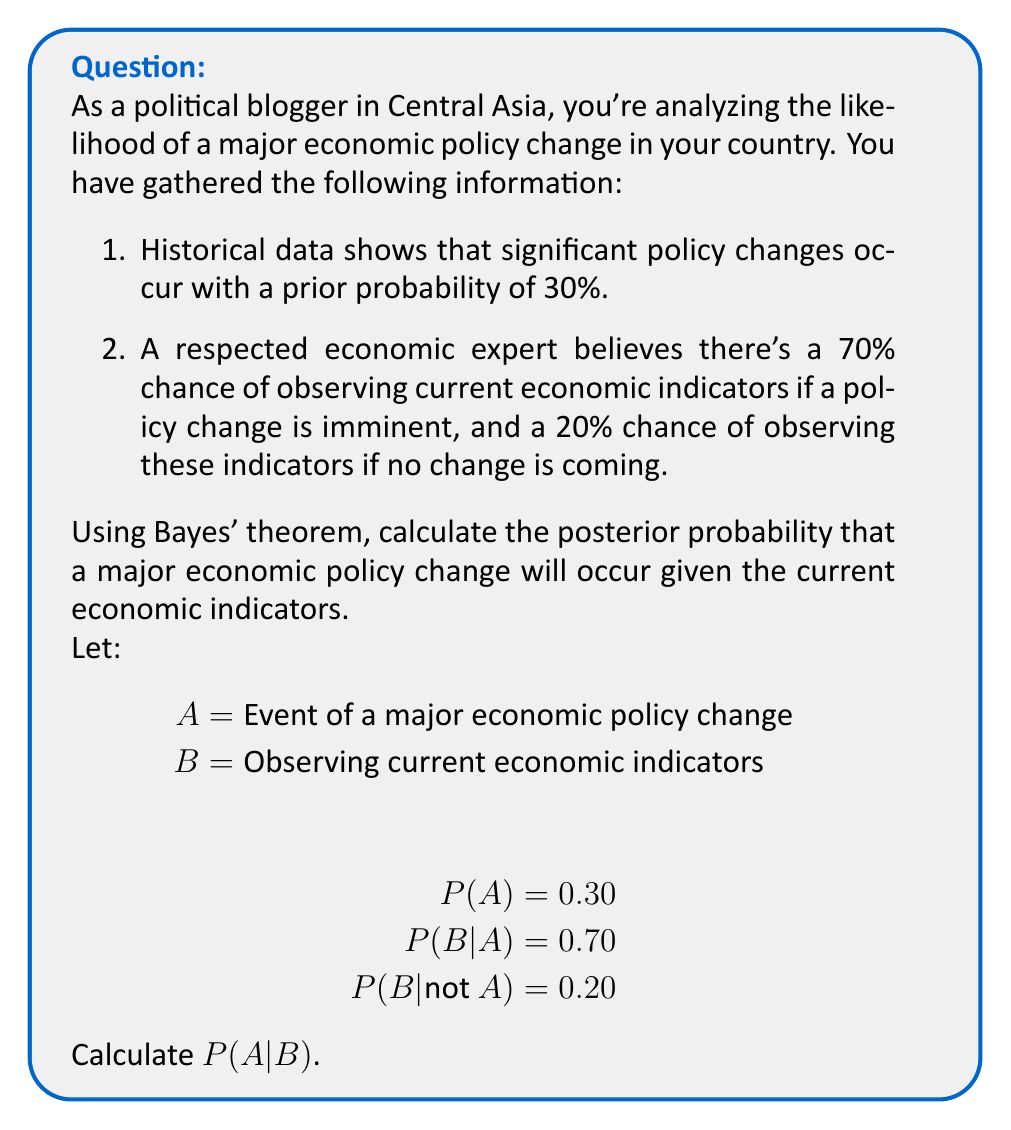Can you solve this math problem? To solve this problem, we'll use Bayes' theorem:

$$P(A|B) = \frac{P(B|A) \cdot P(A)}{P(B)}$$

We're given:
$$P(A) = 0.30$$
$$P(B|A) = 0.70$$
$$P(B|\text{not }A) = 0.20$$

Step 1: Calculate $P(B)$ using the law of total probability:
$$P(B) = P(B|A) \cdot P(A) + P(B|\text{not }A) \cdot P(\text{not }A)$$
$$P(B) = 0.70 \cdot 0.30 + 0.20 \cdot (1 - 0.30)$$
$$P(B) = 0.21 + 0.14 = 0.35$$

Step 2: Apply Bayes' theorem:
$$P(A|B) = \frac{P(B|A) \cdot P(A)}{P(B)}$$
$$P(A|B) = \frac{0.70 \cdot 0.30}{0.35}$$
$$P(A|B) = \frac{0.21}{0.35} = 0.60$$

Therefore, the posterior probability of a major economic policy change occurring, given the current economic indicators, is 0.60 or 60%.
Answer: 0.60 (or 60%) 